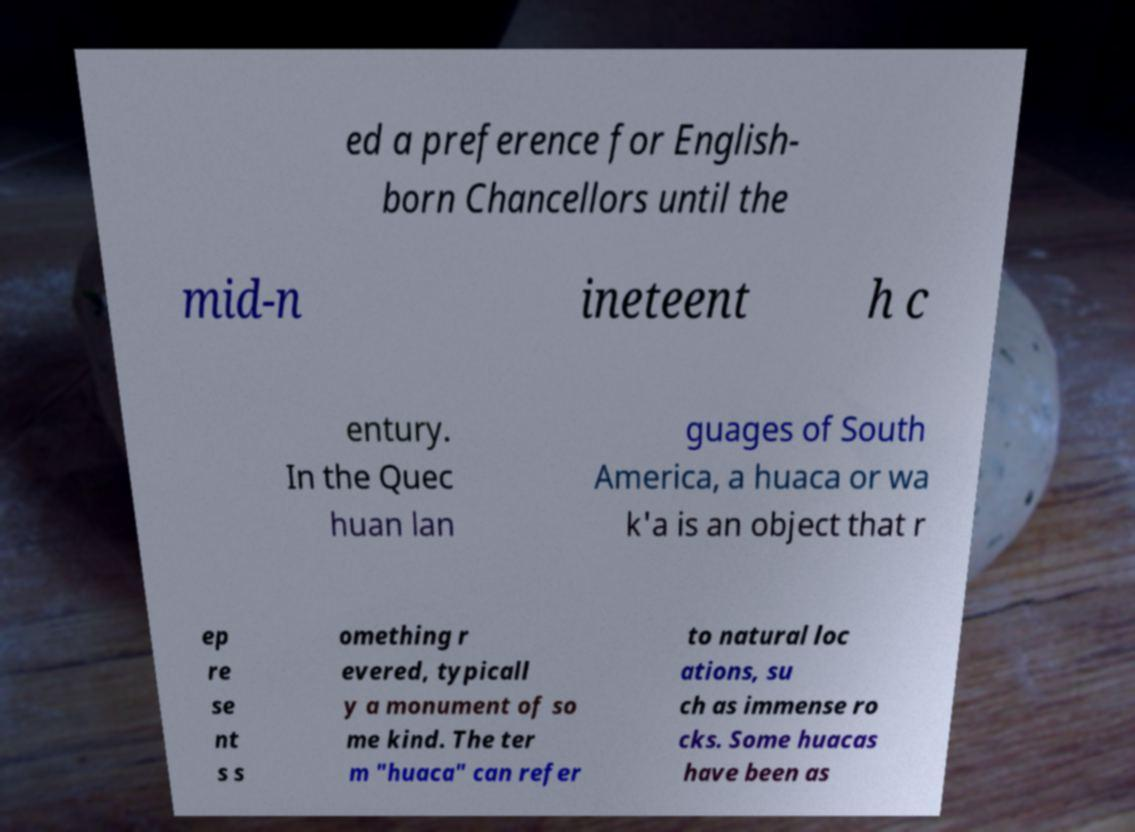Can you accurately transcribe the text from the provided image for me? ed a preference for English- born Chancellors until the mid-n ineteent h c entury. In the Quec huan lan guages of South America, a huaca or wa k'a is an object that r ep re se nt s s omething r evered, typicall y a monument of so me kind. The ter m "huaca" can refer to natural loc ations, su ch as immense ro cks. Some huacas have been as 